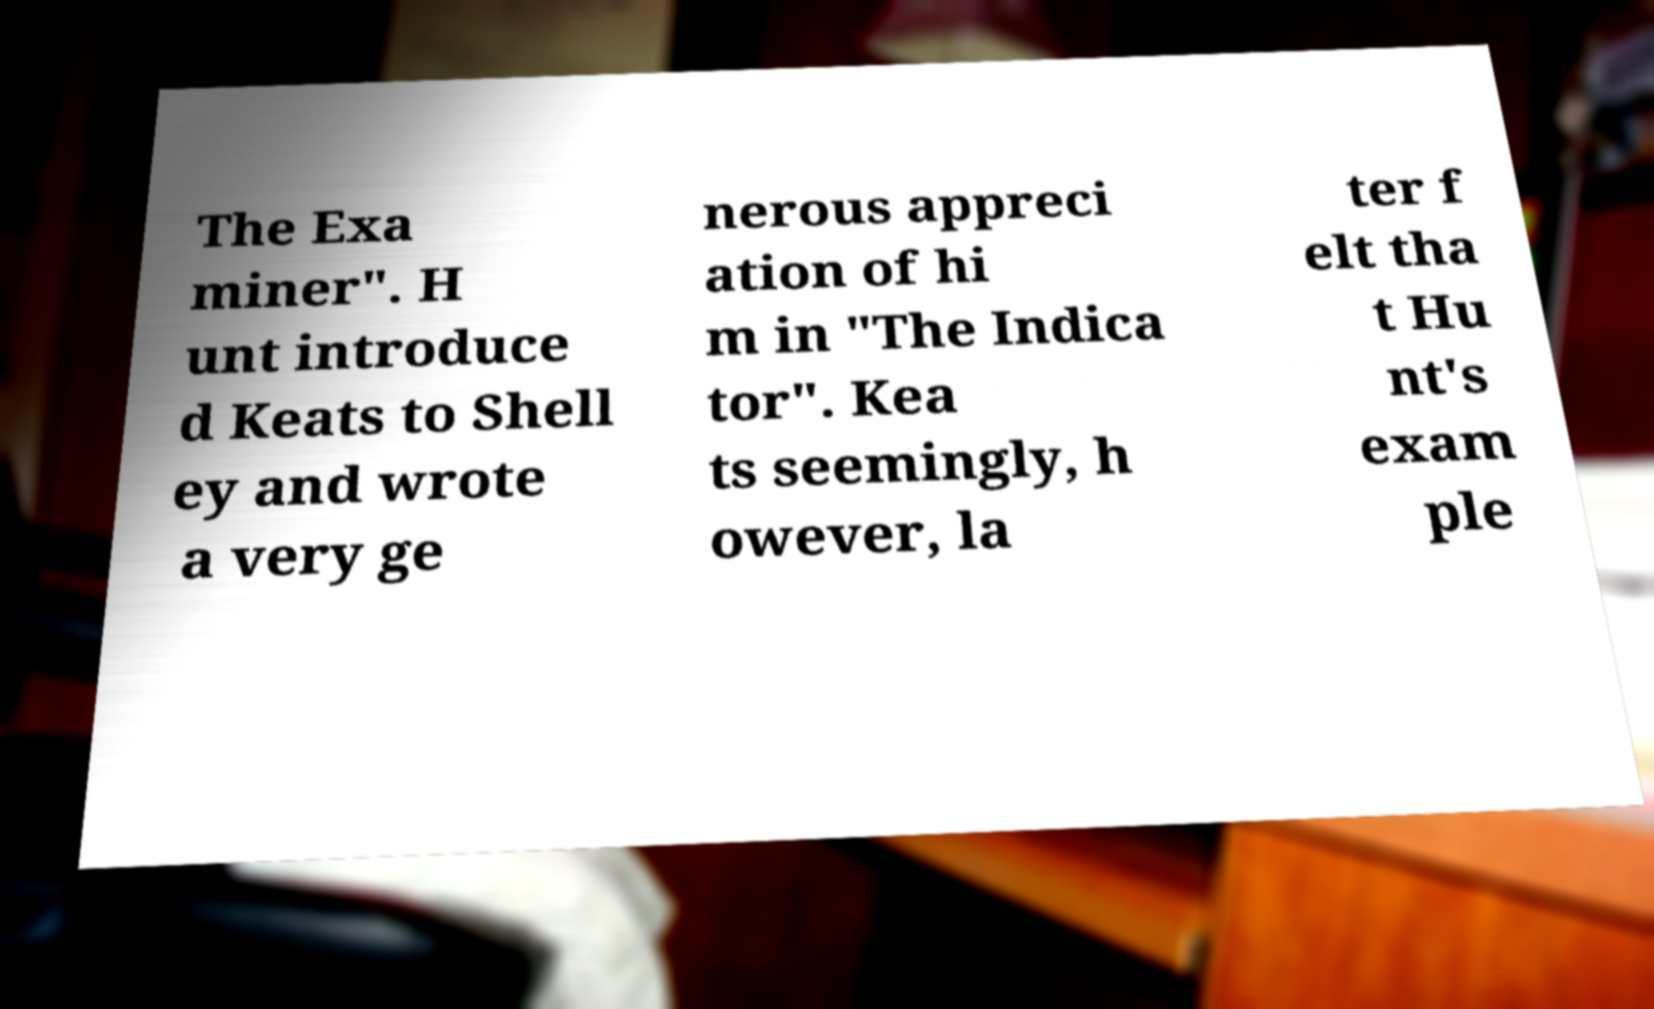Please identify and transcribe the text found in this image. The Exa miner". H unt introduce d Keats to Shell ey and wrote a very ge nerous appreci ation of hi m in "The Indica tor". Kea ts seemingly, h owever, la ter f elt tha t Hu nt's exam ple 